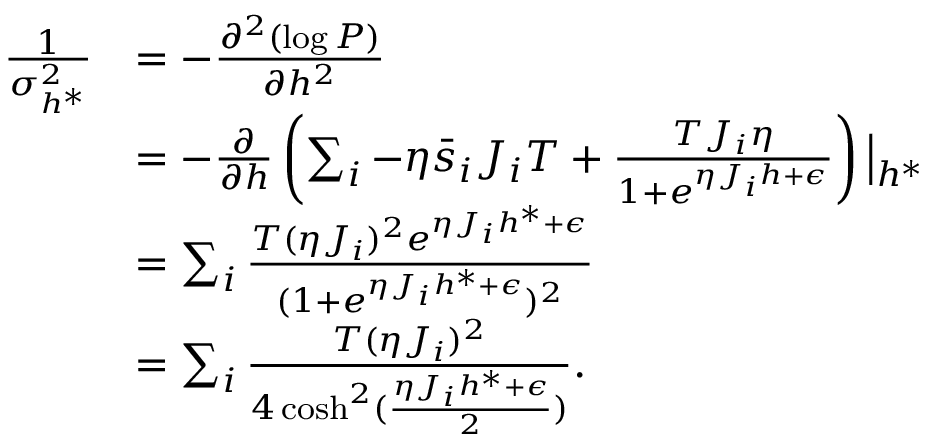Convert formula to latex. <formula><loc_0><loc_0><loc_500><loc_500>\begin{array} { r l } { \frac { 1 } { \sigma _ { h ^ { * } } ^ { 2 } } } & { = - \frac { \partial ^ { 2 } ( \log P ) } { \partial h ^ { 2 } } } \\ & { = - \frac { \partial } { \partial h } \left ( \sum _ { i } - \eta \bar { s } _ { i } J _ { i } T + \frac { T J _ { i } \eta } { 1 + e ^ { \eta J _ { i } h + \epsilon } } \right ) \left | _ { h ^ { * } } } \\ & { = \sum _ { i } \frac { T ( \eta J _ { i } ) ^ { 2 } e ^ { \eta J _ { i } h ^ { * } + \epsilon } } { ( 1 + e ^ { \eta J _ { i } h ^ { * } + \epsilon } ) ^ { 2 } } } \\ & { = \sum _ { i } \frac { T ( \eta J _ { i } ) ^ { 2 } } { 4 \cosh ^ { 2 } ( \frac { \eta J _ { i } h ^ { * } + \epsilon } { 2 } ) } . } \end{array}</formula> 